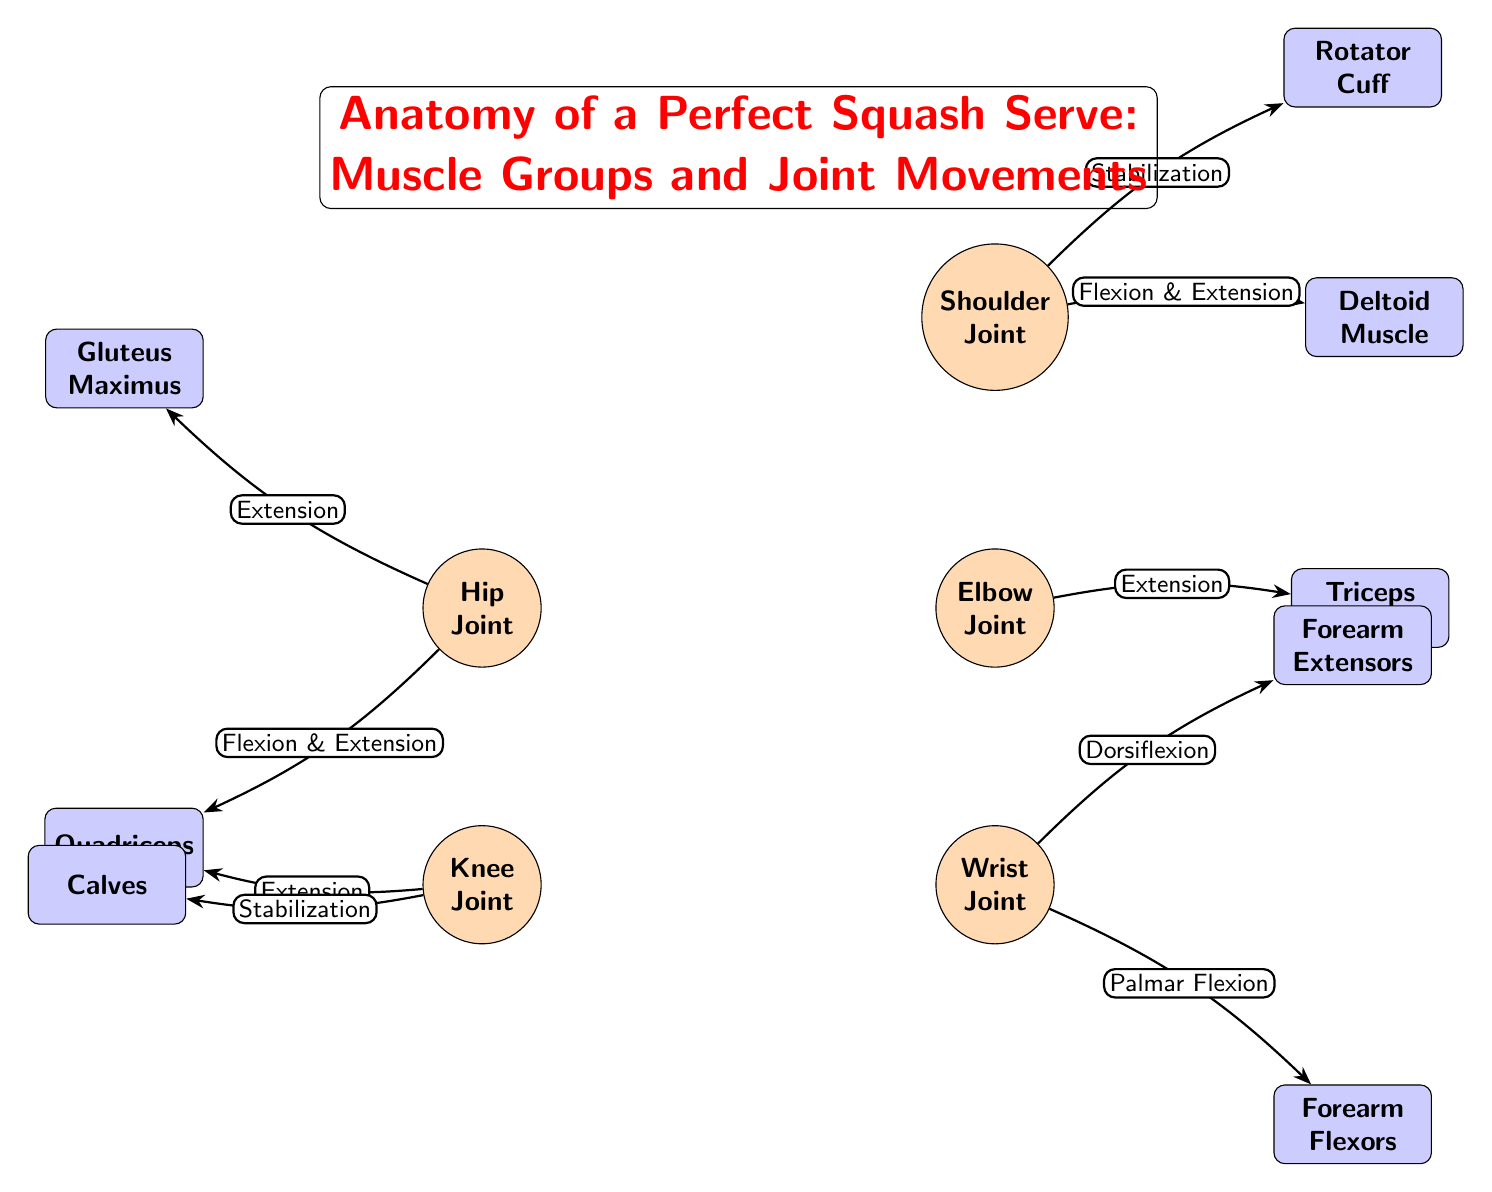What joint is responsible for shoulder movements? The question specifically asks for the joint associated with shoulder movements depicted in the diagram, which is clearly labeled as "Shoulder Joint."
Answer: Shoulder Joint Which muscle stabilizes the shoulder joint? The diagram indicates that the Rotator Cuff muscle is associated with stabilization at the shoulder joint. Thus, the answer is derived from the relationship shown in the diagram.
Answer: Rotator Cuff How many muscle groups are linked to the elbow joint? The diagram shows one prominent muscle, the Triceps Muscle, connected to the elbow joint. Therefore, the answer is derived by counting the muscle representations linked from the elbow joint, which results in one muscle.
Answer: 1 What movement is associated with the wrist joint and the forearm extensors? The diagram describes "Dorsiflexion" as the movement linked between the wrist joint and forearm extensors. This indicates the action that occurs relating these elements.
Answer: Dorsiflexion Which muscle group is involved in hip joint extension? According to the diagram, the Gluteus Maximus muscle is indicated as involved in extension movements of the hip joint, providing the concise answer needed for this question.
Answer: Gluteus Maximus How many joints are illustrated in the diagram? A visual inspection of the diagram reveals four distinct joints: Shoulder, Elbow, Wrist, and Hip, resulting in a total count of joints.
Answer: 4 What is the relationship between the knee joint and the quadriceps muscle? The diagram indicates two relationships: "Extension" and "Stabilization" link the knee joint to the quadriceps muscle, revealing a more detailed view of how these elements interact.
Answer: Extension & Stabilization What is the action performed by the forearm flexors at the wrist joint? The diagram specifically shows "Palmar Flexion" as the corresponding action associated with the wrist joint and forearm flexors. Thus, the answer comes directly from this labeled part of the diagram.
Answer: Palmar Flexion How do the hip and knee joints interact with the quadriceps muscle? The diagram shows that the quadriceps muscle is linked to both the hip joint with "Flexion & Extension" and the knee joint with "Extension." This highlights the functional relationships of the quadriceps across both joints.
Answer: Flexion & Extension; Extension 